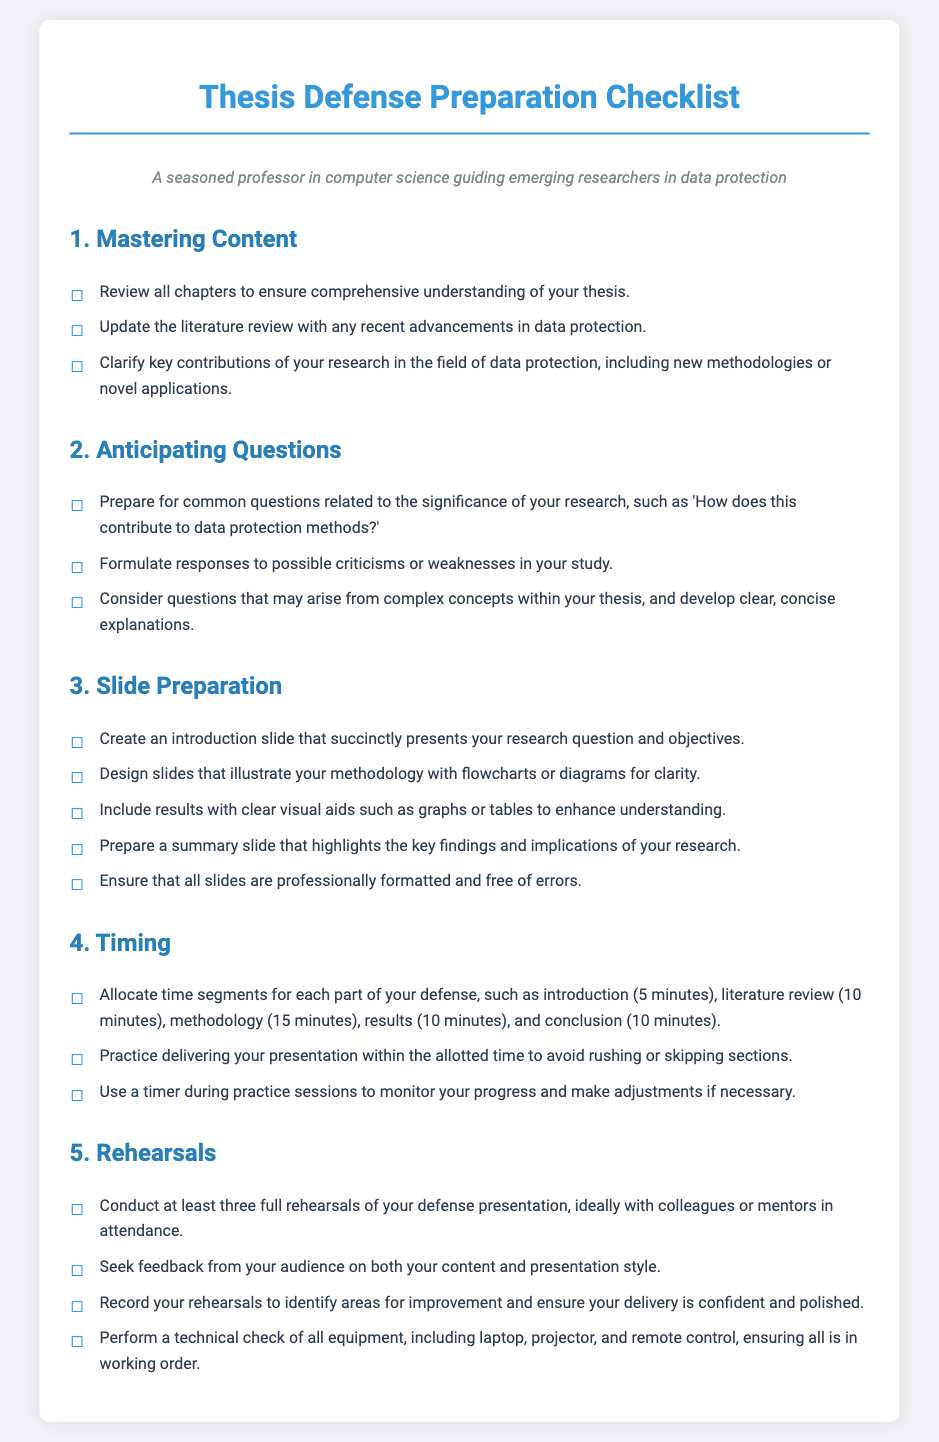What is the title of the document? The title is the heading that encapsulates the main subject matter of the document, which is found at the top.
Answer: Thesis Defense Preparation Checklist How many sections are in the checklist? The sections can be counted by looking at the subheadings in the document.
Answer: Five What is the first step in mastering content? The first step is the action that needs to be taken to ensure a strong understanding of the thesis content.
Answer: Review all chapters to ensure comprehensive understanding of your thesis What is a recommended duration for the introduction segment of the defense? The recommended duration is specified under the timing section for structuring the defense presentation.
Answer: Five minutes What is one method to prepare a slide about the methodology? This refers to a specific action to visually represent the methodology in the slides.
Answer: Design slides that illustrate your methodology with flowcharts or diagrams for clarity How many rehearsals are suggested to practice the defense presentation? This number can be found mentioned in the rehearsals section of the checklist.
Answer: At least three What type of feedback should be sought during rehearsals? The feedback type is specified for the audience's input regarding both presentation aspects.
Answer: Content and presentation style What should be included in the summary slide? This item outlines what information should be encapsulated in the final slide of the presentation.
Answer: Key findings and implications of your research 